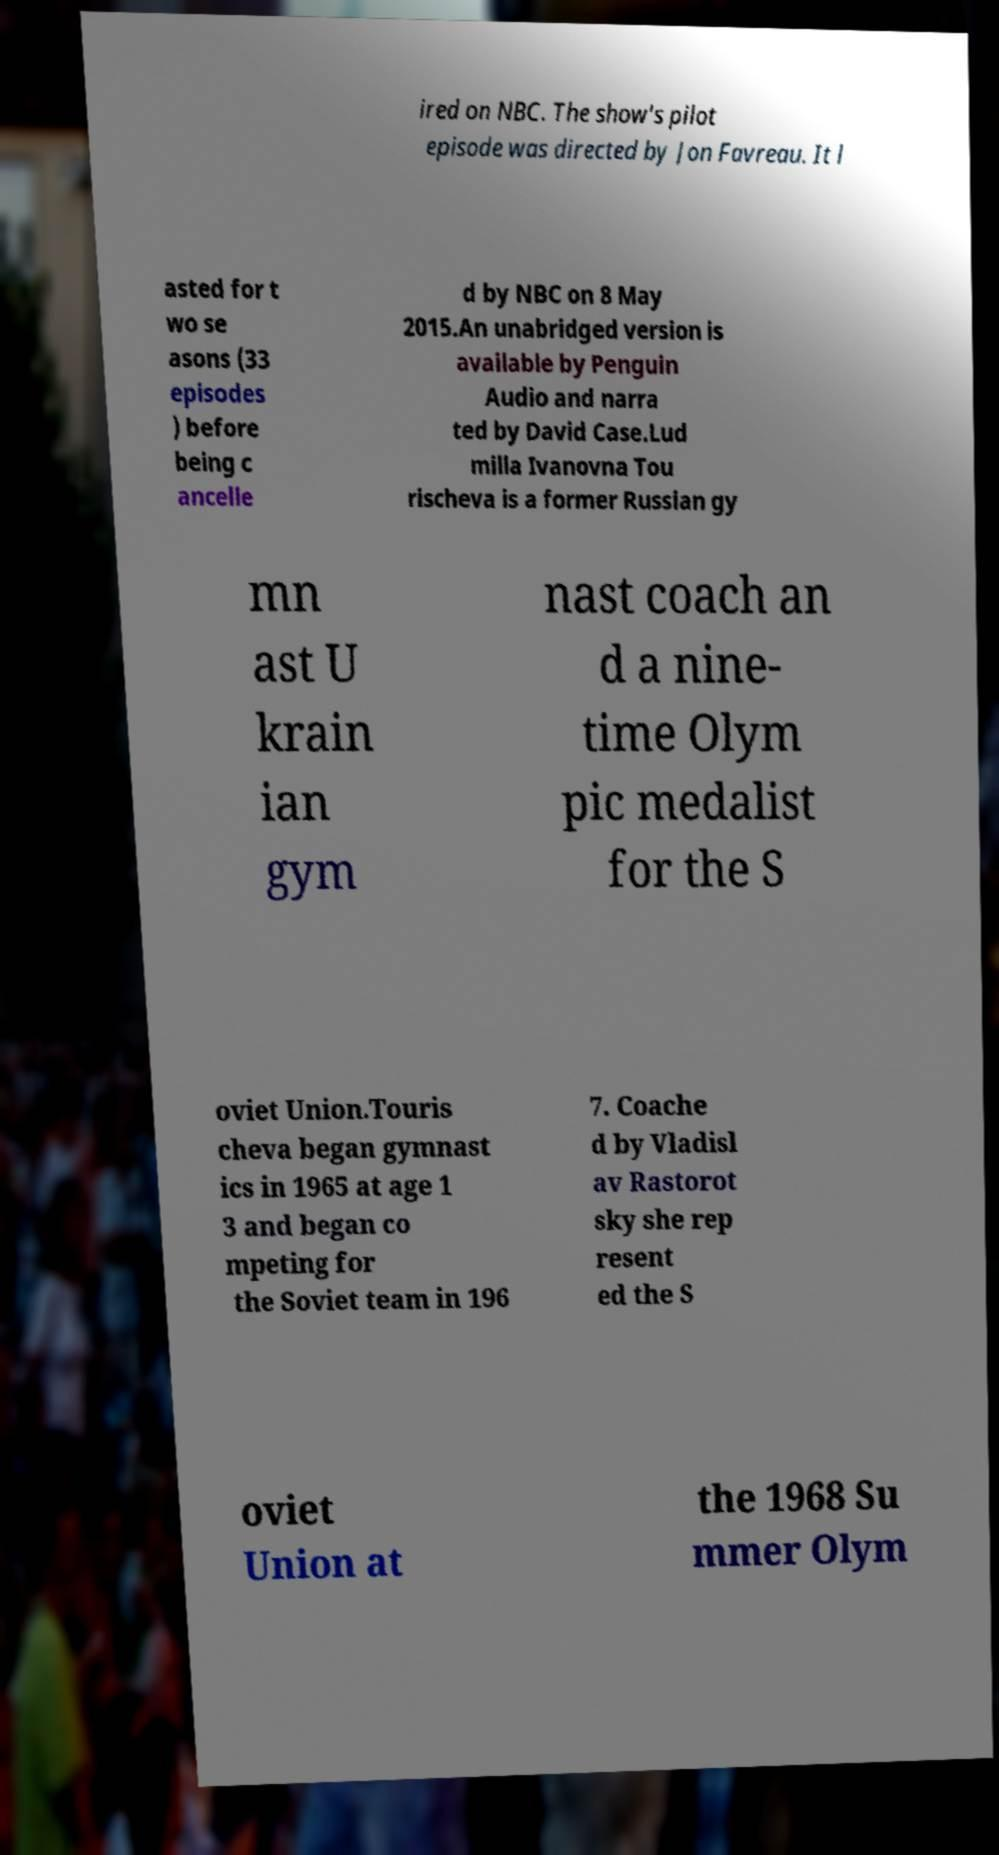Could you assist in decoding the text presented in this image and type it out clearly? ired on NBC. The show's pilot episode was directed by Jon Favreau. It l asted for t wo se asons (33 episodes ) before being c ancelle d by NBC on 8 May 2015.An unabridged version is available by Penguin Audio and narra ted by David Case.Lud milla Ivanovna Tou rischeva is a former Russian gy mn ast U krain ian gym nast coach an d a nine- time Olym pic medalist for the S oviet Union.Touris cheva began gymnast ics in 1965 at age 1 3 and began co mpeting for the Soviet team in 196 7. Coache d by Vladisl av Rastorot sky she rep resent ed the S oviet Union at the 1968 Su mmer Olym 